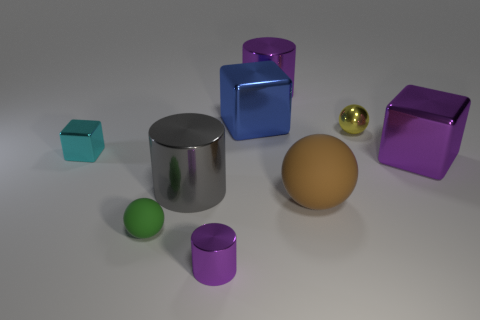Subtract all small spheres. How many spheres are left? 1 Subtract 1 cylinders. How many cylinders are left? 2 Subtract all blue blocks. How many blocks are left? 2 Subtract all blocks. How many objects are left? 6 Subtract 1 cyan cubes. How many objects are left? 8 Subtract all red blocks. Subtract all blue balls. How many blocks are left? 3 Subtract all purple cylinders. How many yellow cubes are left? 0 Subtract all large blue shiny objects. Subtract all big cyan rubber things. How many objects are left? 8 Add 5 metal cubes. How many metal cubes are left? 8 Add 7 purple cylinders. How many purple cylinders exist? 9 